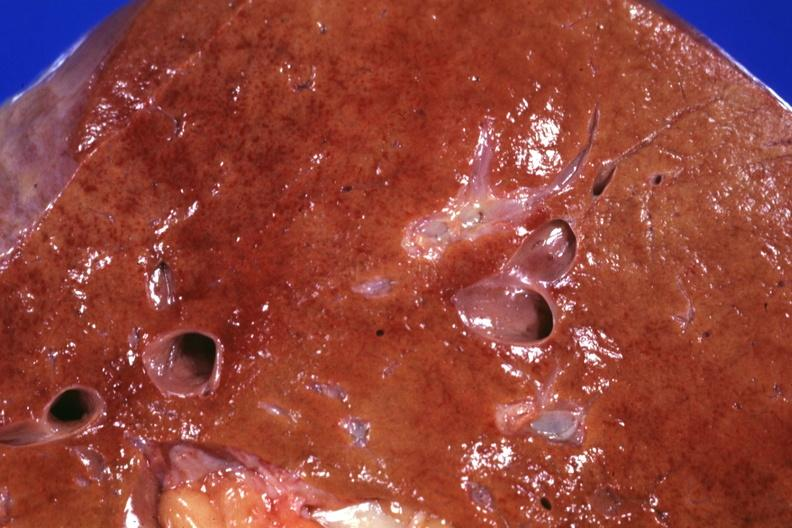does this image show close-up fatty with congestion and areas that suggest necrosis grossly good example shock liver?
Answer the question using a single word or phrase. Yes 